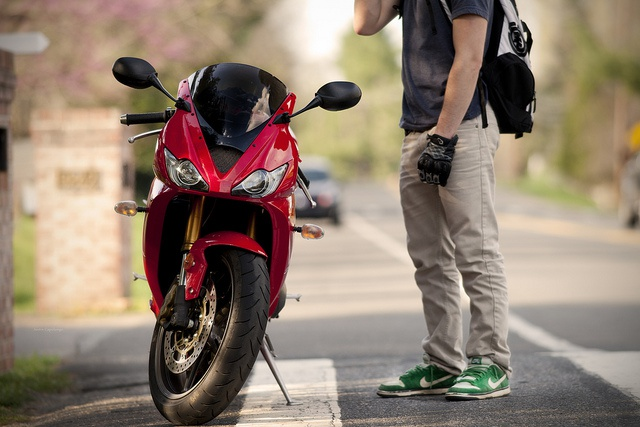Describe the objects in this image and their specific colors. I can see motorcycle in gray, black, maroon, and brown tones, people in gray, black, and darkgray tones, backpack in gray, black, darkgray, tan, and lightgray tones, and car in gray, darkgray, black, and lightgray tones in this image. 